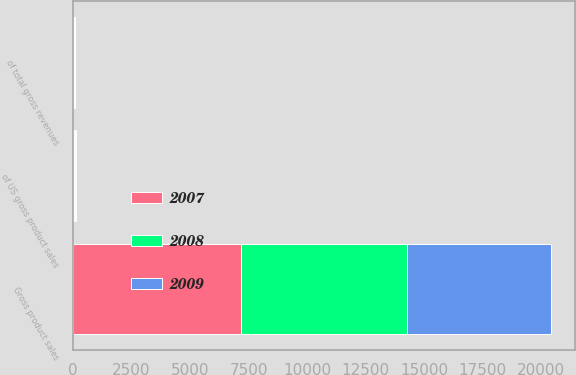Convert chart to OTSL. <chart><loc_0><loc_0><loc_500><loc_500><stacked_bar_chart><ecel><fcel>Gross product sales<fcel>of total gross revenues<fcel>of US gross product sales<nl><fcel>2007<fcel>7179<fcel>37<fcel>46<nl><fcel>2008<fcel>7099<fcel>37<fcel>46<nl><fcel>2009<fcel>6124<fcel>31<fcel>39<nl></chart> 